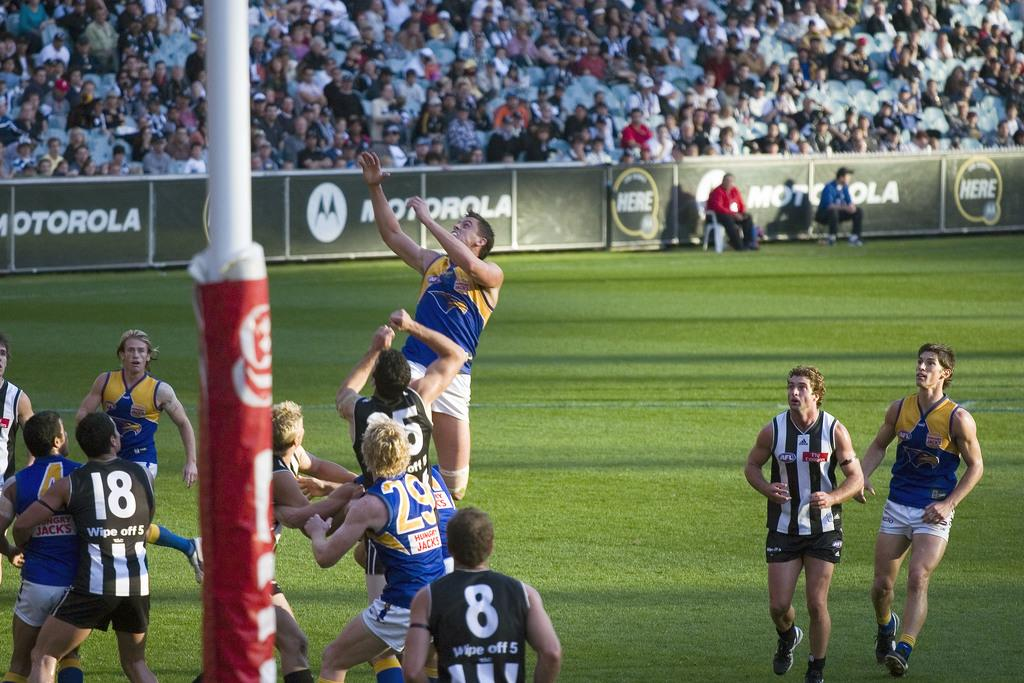<image>
Render a clear and concise summary of the photo. A rugby match is being played in a field with the motorola advertisement in the background. 